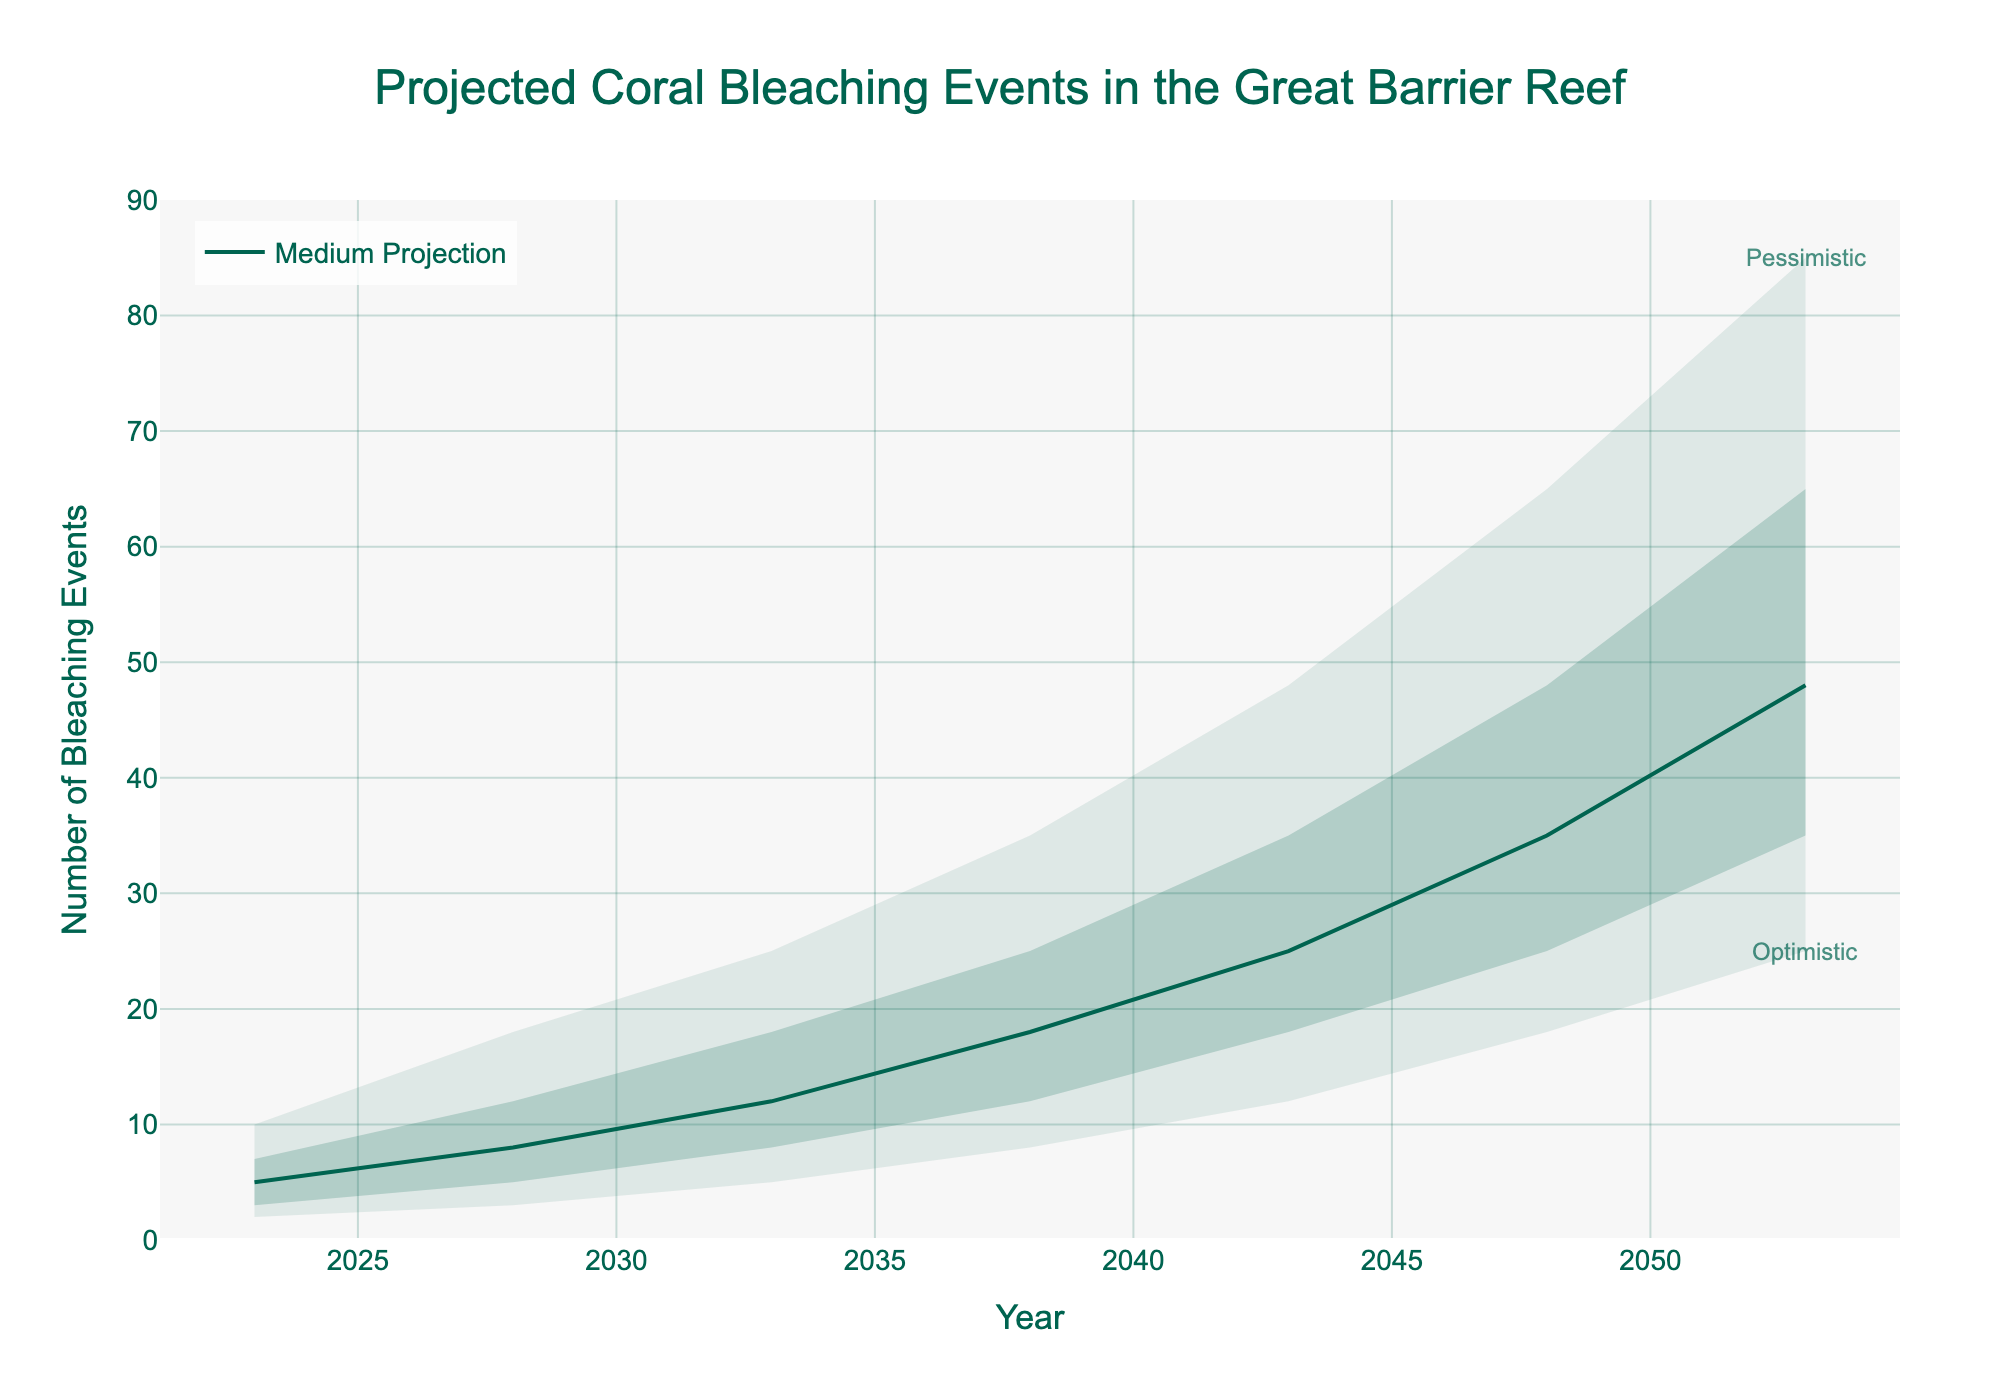What is the title of the chart? The title is displayed at the top center of the chart.
Answer: Projected Coral Bleaching Events in the Great Barrier Reef What are the units used on the y-axis? The y-axis units are given in the axis title on the left side of the chart.
Answer: Number of Bleaching Events In what year is the number of pessimistic bleaching events projected to reach 48? Look at the intersection of the "Pessimistic" area with the y-axis value of 48 and trace back to the year on the x-axis.
Answer: 2043 Compare the optimistic projections for the years 2023 and 2028. How many more bleaching events are projected in 2028 than in 2023? Subtract the number of optimistic bleaching events in 2023 from that in 2028: (3 - 2).
Answer: 1 By how much do the medium projections for bleaching events increase from 2023 to 2053? Subtract the medium projection in 2023 from that in 2053: (48 - 5).
Answer: 43 Which range of projections are shown as shaded areas? The shaded areas represent the ranges between optimistic to high and low to pessimistic projections which are identified through the gradient shading.
Answer: Optimistic to High and Low to Pessimistic Between which years do the medium projections of bleaching events jump from 12 to 25? Identify the medium projection values and the corresponding years where the increase occurs.
Answer: 2038 to 2043 What is the difference between the high projection and the low projection for the year 2033? Subtract the low projection from the high projection for the year 2033: (18 - 8).
Answer: 10 Which projection line is explicitly labeled on the chart? The line explicitly labeled on the chart is the one representing a single projection scenario.
Answer: Medium Projection How does the range between pessimistic and optimistic projections change from 2023 to 2053? Calculate the ranges for 2023 (10 - 2) = 8 and for 2053 (85 - 25) = 60, and then compare them.
Answer: It increases by 52 